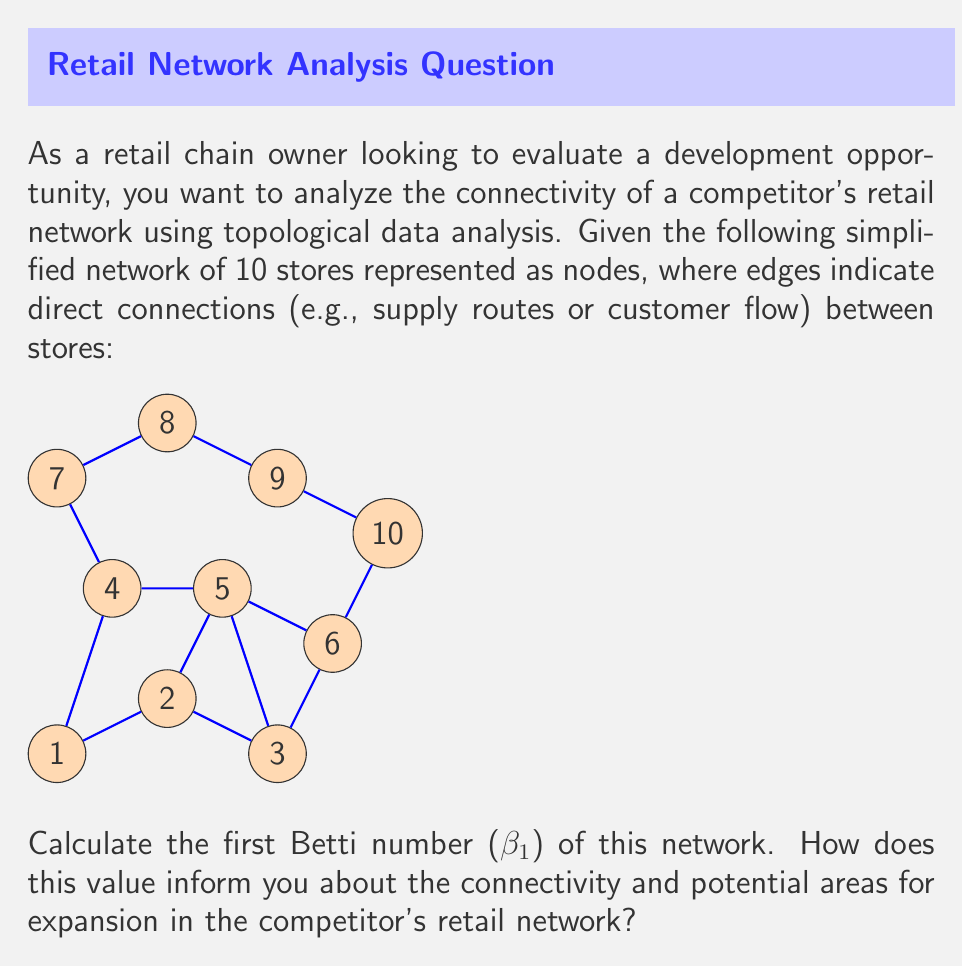Provide a solution to this math problem. To solve this problem, we'll follow these steps:

1) First, let's understand what the first Betti number (β₁) represents in topological data analysis:
   - β₁ counts the number of 1-dimensional holes or loops in the network.
   - It gives us information about the connectivity and redundancy in the network.

2) To calculate β₁, we need to:
   a) Count the number of vertices (V)
   b) Count the number of edges (E)
   c) Count the number of connected components (C)
   d) Apply the formula: β₁ = E - V + C

3) Counting from the given network:
   a) V = 10 (numbered from 1 to 10)
   b) E = 13 (count all lines connecting the dots)
   c) C = 1 (all nodes are connected in one component)

4) Applying the formula:
   β₁ = E - V + C
   β₁ = 13 - 10 + 1 = 4

5) Interpretation:
   - A β₁ of 4 indicates that there are 4 loops or cycles in the network.
   - These loops represent redundant connections or alternative paths between stores.
   - From a business perspective:
     * Higher connectivity suggests a more resilient supply chain and customer flow.
     * Areas without loops might be potential weak points or opportunities for expansion.
     * The competitor's network has a moderate level of connectivity, with some redundancy but also room for improvement.

6) Potential areas for expansion:
   - Look for "bridges" or critical connections that, if removed, would disconnect the network.
   - Consider adding connections to create more loops, especially in areas with fewer redundant paths.
   - For example, connecting stores 6 and 8 could create an additional loop and improve overall connectivity.

This topological analysis provides insights into the structure and resilience of the competitor's network, helping inform strategic decisions for your own retail chain development.
Answer: β₁ = 4 